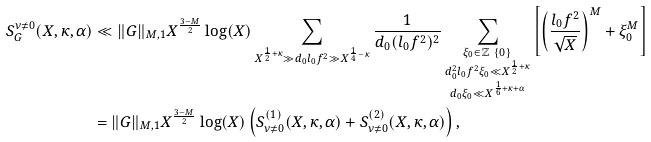<formula> <loc_0><loc_0><loc_500><loc_500>S _ { G } ^ { \nu \neq 0 } ( X , \kappa , \alpha ) & \ll \| G \| _ { M , 1 } X ^ { \frac { 3 - M } { 2 } } \log ( X ) \sum _ { X ^ { \frac { 1 } { 2 } + \kappa } \gg d _ { 0 } l _ { 0 } f ^ { 2 } \gg X ^ { \frac { 1 } { 4 } - \kappa } } \frac { 1 } { d _ { 0 } ( l _ { 0 } f ^ { 2 } ) ^ { 2 } } \sum _ { \substack { \xi _ { 0 } \in \mathbb { Z } \ \{ 0 \} \\ d _ { 0 } ^ { 2 } l _ { 0 } f ^ { 2 } \xi _ { 0 } \ll X ^ { \frac { 1 } { 2 } + \kappa } \\ d _ { 0 } \xi _ { 0 } \ll X ^ { \frac { 1 } { 6 } + \kappa + \alpha } } } \left [ \left ( \frac { l _ { 0 } f ^ { 2 } } { \sqrt { X } } \right ) ^ { M } + \xi _ { 0 } ^ { M } \right ] \\ & = \| G \| _ { M , 1 } X ^ { \frac { 3 - M } { 2 } } \log ( X ) \left ( S _ { \nu \neq 0 } ^ { ( 1 ) } ( X , \kappa , \alpha ) + S _ { \nu \neq 0 } ^ { ( 2 ) } ( X , \kappa , \alpha ) \right ) ,</formula> 